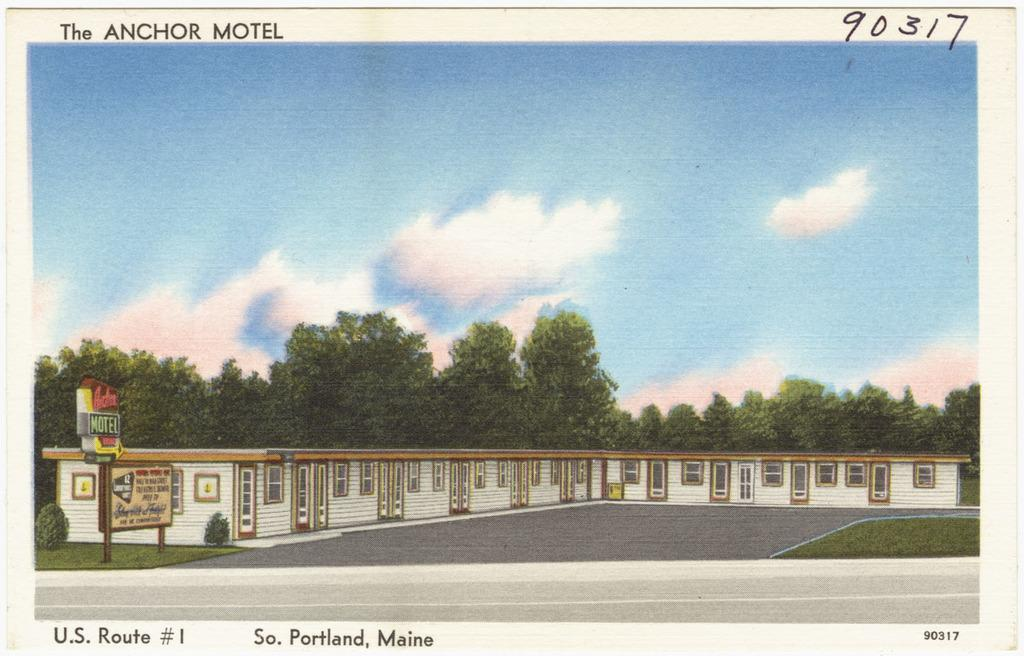What type of structure is present in the image? There is a building in the image. What other objects can be seen in the image? There is a pole, boards, plants, trees, and grass in the image. Can you describe the natural elements in the image? There are plants, trees, and grass in the image. What is visible in the background of the image? The sky is visible in the background of the image. How many beds are visible in the image? There are no beds present in the image. What type of clouds can be seen in the image? The provided facts do not mention any clouds in the image. 